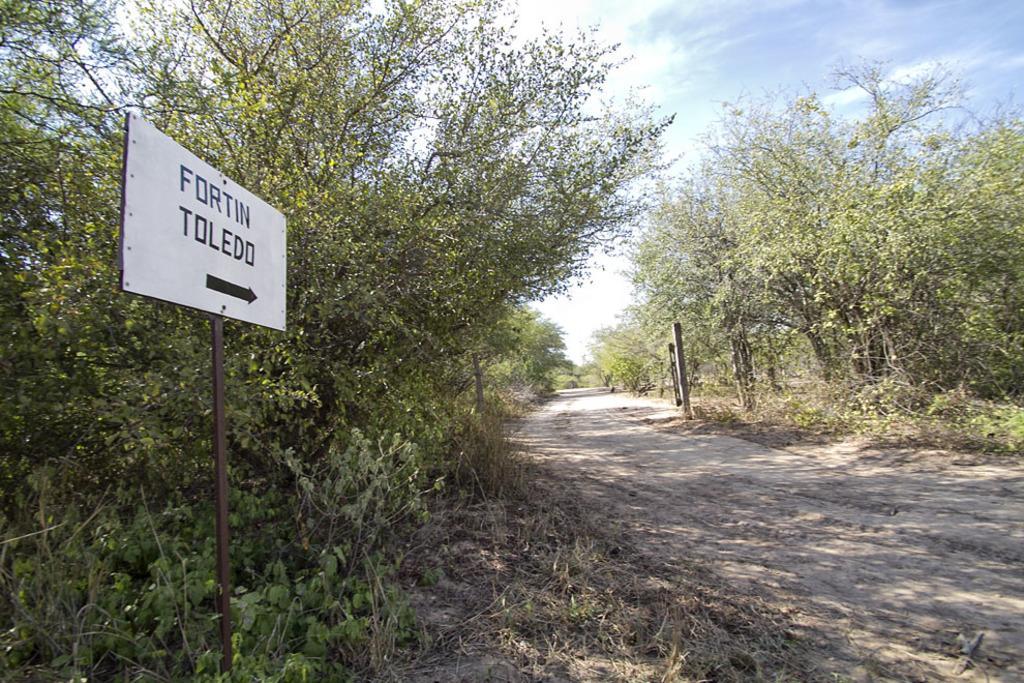In one or two sentences, can you explain what this image depicts? This image consists of a road. On the left, there is a board. At the top, there is sky. On the left and right, there are trees. At the bottom, we can see the dry grass. 